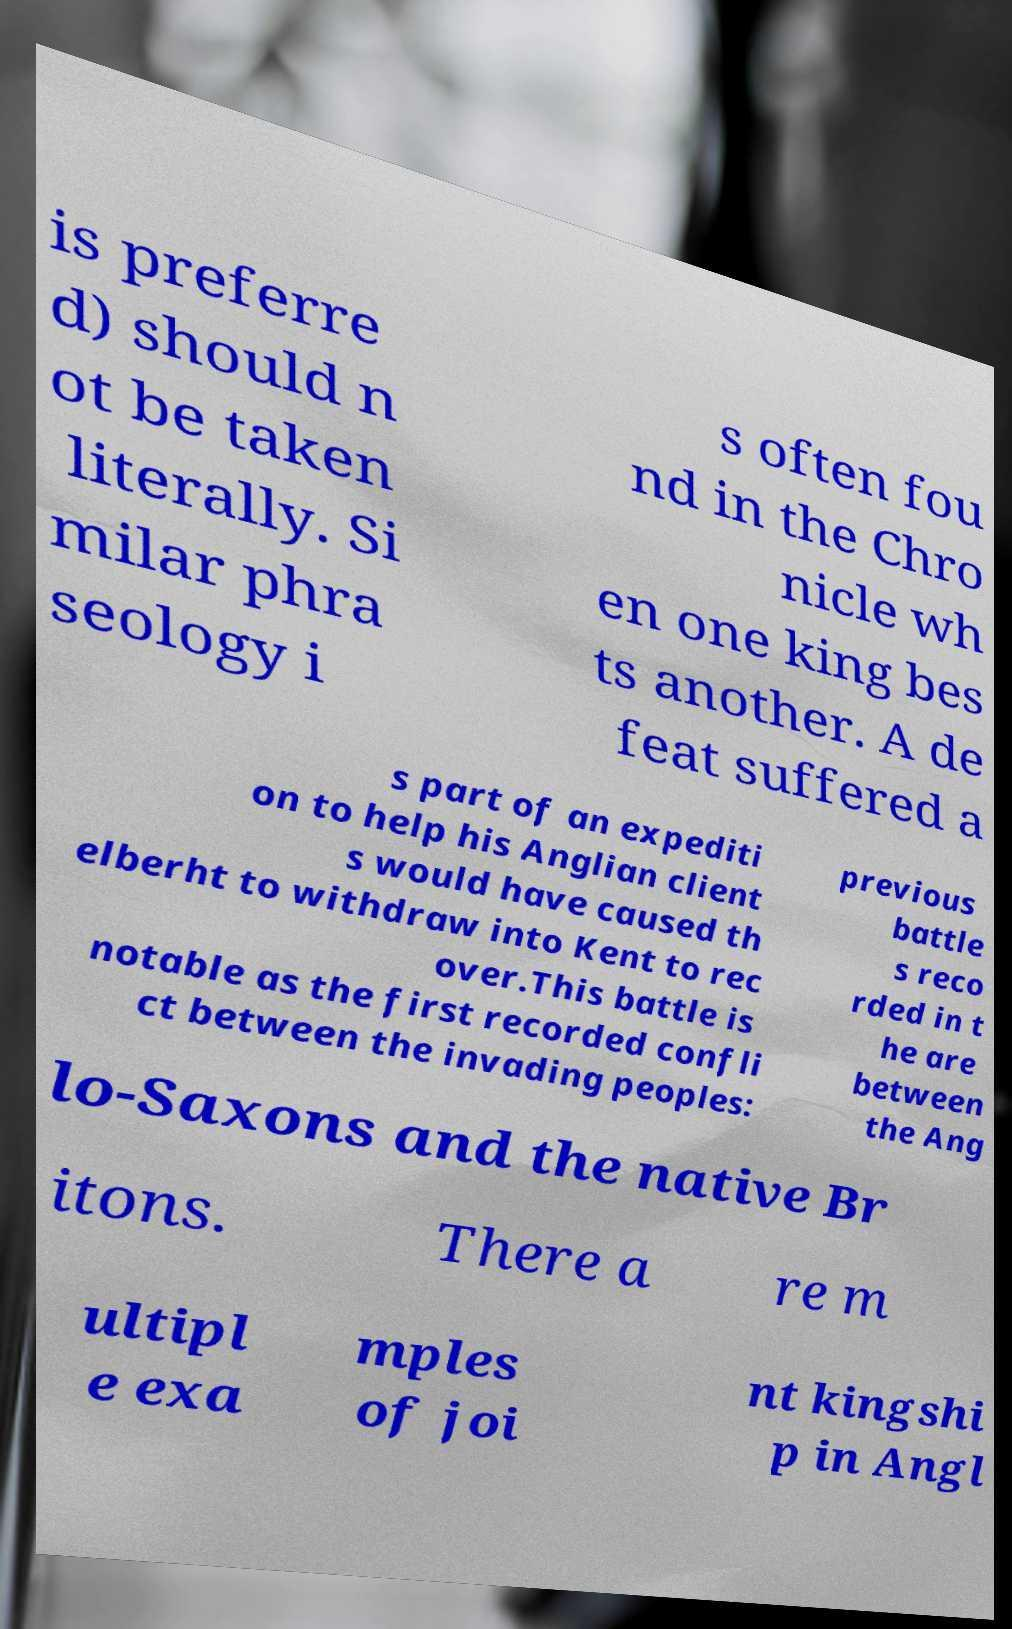Please read and relay the text visible in this image. What does it say? is preferre d) should n ot be taken literally. Si milar phra seology i s often fou nd in the Chro nicle wh en one king bes ts another. A de feat suffered a s part of an expediti on to help his Anglian client s would have caused th elberht to withdraw into Kent to rec over.This battle is notable as the first recorded confli ct between the invading peoples: previous battle s reco rded in t he are between the Ang lo-Saxons and the native Br itons. There a re m ultipl e exa mples of joi nt kingshi p in Angl 